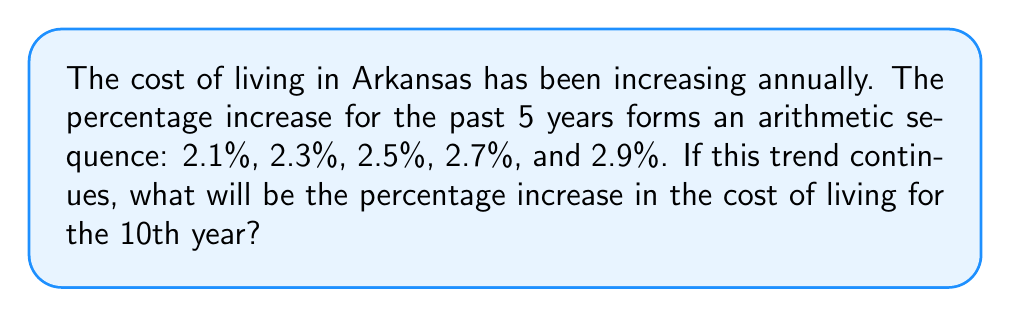Could you help me with this problem? Let's approach this step-by-step:

1) First, we need to identify the arithmetic sequence:
   $a_1 = 2.1\%$, $a_2 = 2.3\%$, $a_3 = 2.5\%$, $a_4 = 2.7\%$, $a_5 = 2.9\%$

2) In an arithmetic sequence, the difference between any two consecutive terms is constant. Let's call this common difference $d$:
   $d = a_2 - a_1 = 2.3\% - 2.1\% = 0.2\%$
   We can verify this for other terms as well.

3) The general formula for the nth term of an arithmetic sequence is:
   $a_n = a_1 + (n-1)d$
   Where $a_1$ is the first term, $n$ is the position of the term we're looking for, and $d$ is the common difference.

4) We're asked about the 10th year, so $n = 10$:
   $a_{10} = 2.1\% + (10-1)(0.2\%)$

5) Let's calculate:
   $a_{10} = 2.1\% + 9(0.2\%)$
   $a_{10} = 2.1\% + 1.8\%$
   $a_{10} = 3.9\%$

Therefore, if the trend continues, the percentage increase in the cost of living for the 10th year will be 3.9%.
Answer: 3.9% 